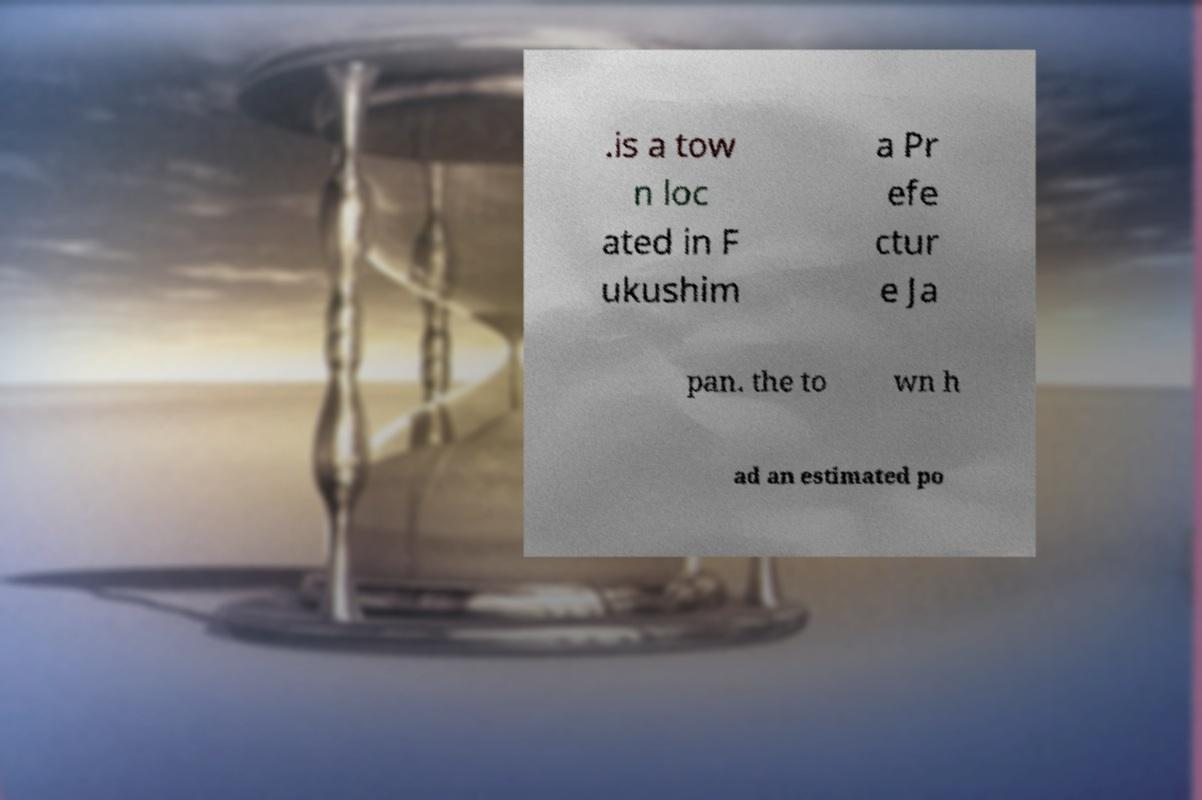Can you accurately transcribe the text from the provided image for me? .is a tow n loc ated in F ukushim a Pr efe ctur e Ja pan. the to wn h ad an estimated po 